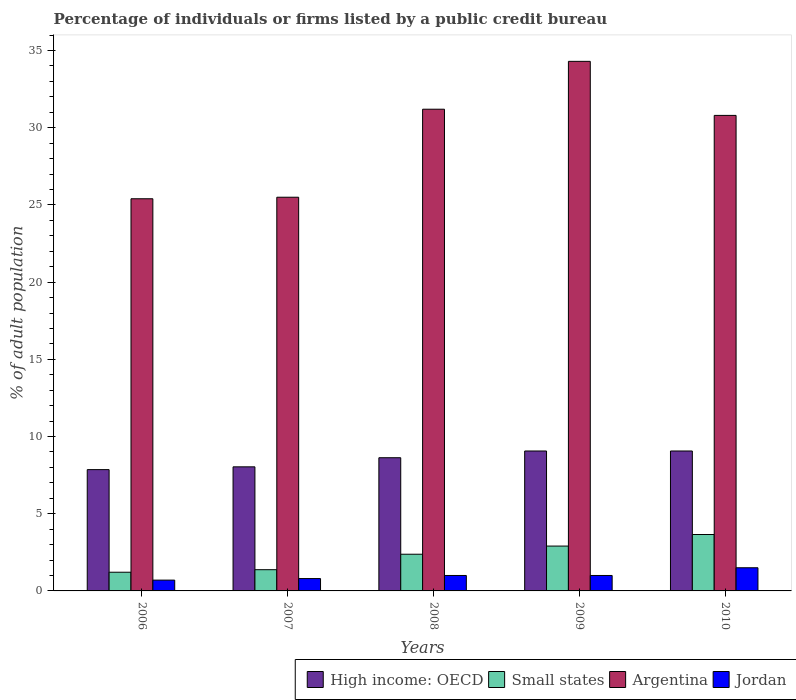How many different coloured bars are there?
Offer a terse response. 4. How many groups of bars are there?
Offer a terse response. 5. Are the number of bars per tick equal to the number of legend labels?
Your answer should be compact. Yes. Are the number of bars on each tick of the X-axis equal?
Make the answer very short. Yes. What is the label of the 3rd group of bars from the left?
Keep it short and to the point. 2008. In how many cases, is the number of bars for a given year not equal to the number of legend labels?
Give a very brief answer. 0. What is the percentage of population listed by a public credit bureau in Small states in 2008?
Make the answer very short. 2.38. Across all years, what is the maximum percentage of population listed by a public credit bureau in High income: OECD?
Ensure brevity in your answer.  9.06. Across all years, what is the minimum percentage of population listed by a public credit bureau in High income: OECD?
Your response must be concise. 7.86. In which year was the percentage of population listed by a public credit bureau in Small states maximum?
Your response must be concise. 2010. In which year was the percentage of population listed by a public credit bureau in Small states minimum?
Your response must be concise. 2006. What is the difference between the percentage of population listed by a public credit bureau in High income: OECD in 2007 and that in 2008?
Provide a short and direct response. -0.59. What is the difference between the percentage of population listed by a public credit bureau in Jordan in 2008 and the percentage of population listed by a public credit bureau in High income: OECD in 2006?
Your response must be concise. -6.86. What is the average percentage of population listed by a public credit bureau in Jordan per year?
Your answer should be very brief. 1. In the year 2007, what is the difference between the percentage of population listed by a public credit bureau in Argentina and percentage of population listed by a public credit bureau in High income: OECD?
Give a very brief answer. 17.46. In how many years, is the percentage of population listed by a public credit bureau in Small states greater than 22 %?
Your answer should be compact. 0. What is the ratio of the percentage of population listed by a public credit bureau in Small states in 2007 to that in 2009?
Offer a very short reply. 0.47. Is the percentage of population listed by a public credit bureau in Small states in 2009 less than that in 2010?
Offer a terse response. Yes. What is the difference between the highest and the lowest percentage of population listed by a public credit bureau in Argentina?
Provide a succinct answer. 8.9. In how many years, is the percentage of population listed by a public credit bureau in Small states greater than the average percentage of population listed by a public credit bureau in Small states taken over all years?
Your response must be concise. 3. What does the 2nd bar from the left in 2007 represents?
Offer a terse response. Small states. What does the 2nd bar from the right in 2009 represents?
Keep it short and to the point. Argentina. Are all the bars in the graph horizontal?
Your answer should be very brief. No. How many years are there in the graph?
Your response must be concise. 5. Are the values on the major ticks of Y-axis written in scientific E-notation?
Your answer should be compact. No. Where does the legend appear in the graph?
Your response must be concise. Bottom right. What is the title of the graph?
Keep it short and to the point. Percentage of individuals or firms listed by a public credit bureau. What is the label or title of the X-axis?
Offer a very short reply. Years. What is the label or title of the Y-axis?
Offer a very short reply. % of adult population. What is the % of adult population in High income: OECD in 2006?
Make the answer very short. 7.86. What is the % of adult population of Small states in 2006?
Offer a terse response. 1.21. What is the % of adult population of Argentina in 2006?
Ensure brevity in your answer.  25.4. What is the % of adult population of High income: OECD in 2007?
Provide a succinct answer. 8.04. What is the % of adult population in Small states in 2007?
Your answer should be very brief. 1.37. What is the % of adult population of Jordan in 2007?
Offer a very short reply. 0.8. What is the % of adult population of High income: OECD in 2008?
Make the answer very short. 8.63. What is the % of adult population in Small states in 2008?
Give a very brief answer. 2.38. What is the % of adult population in Argentina in 2008?
Provide a succinct answer. 31.2. What is the % of adult population in Jordan in 2008?
Give a very brief answer. 1. What is the % of adult population of High income: OECD in 2009?
Give a very brief answer. 9.06. What is the % of adult population of Small states in 2009?
Provide a short and direct response. 2.91. What is the % of adult population of Argentina in 2009?
Your answer should be very brief. 34.3. What is the % of adult population in High income: OECD in 2010?
Provide a succinct answer. 9.06. What is the % of adult population in Small states in 2010?
Provide a short and direct response. 3.65. What is the % of adult population in Argentina in 2010?
Keep it short and to the point. 30.8. Across all years, what is the maximum % of adult population of High income: OECD?
Your response must be concise. 9.06. Across all years, what is the maximum % of adult population of Small states?
Give a very brief answer. 3.65. Across all years, what is the maximum % of adult population in Argentina?
Your response must be concise. 34.3. Across all years, what is the minimum % of adult population in High income: OECD?
Offer a terse response. 7.86. Across all years, what is the minimum % of adult population of Small states?
Ensure brevity in your answer.  1.21. Across all years, what is the minimum % of adult population of Argentina?
Provide a short and direct response. 25.4. What is the total % of adult population in High income: OECD in the graph?
Provide a short and direct response. 42.65. What is the total % of adult population of Small states in the graph?
Your answer should be very brief. 11.52. What is the total % of adult population of Argentina in the graph?
Make the answer very short. 147.2. What is the total % of adult population of Jordan in the graph?
Your answer should be compact. 5. What is the difference between the % of adult population in High income: OECD in 2006 and that in 2007?
Provide a succinct answer. -0.18. What is the difference between the % of adult population of Small states in 2006 and that in 2007?
Keep it short and to the point. -0.16. What is the difference between the % of adult population in High income: OECD in 2006 and that in 2008?
Your answer should be compact. -0.77. What is the difference between the % of adult population of Small states in 2006 and that in 2008?
Keep it short and to the point. -1.17. What is the difference between the % of adult population in Argentina in 2006 and that in 2008?
Provide a succinct answer. -5.8. What is the difference between the % of adult population in High income: OECD in 2006 and that in 2009?
Offer a terse response. -1.21. What is the difference between the % of adult population of Small states in 2006 and that in 2009?
Your answer should be very brief. -1.69. What is the difference between the % of adult population in High income: OECD in 2006 and that in 2010?
Offer a terse response. -1.21. What is the difference between the % of adult population in Small states in 2006 and that in 2010?
Provide a short and direct response. -2.44. What is the difference between the % of adult population of High income: OECD in 2007 and that in 2008?
Ensure brevity in your answer.  -0.59. What is the difference between the % of adult population of Small states in 2007 and that in 2008?
Ensure brevity in your answer.  -1. What is the difference between the % of adult population in Argentina in 2007 and that in 2008?
Offer a very short reply. -5.7. What is the difference between the % of adult population in Jordan in 2007 and that in 2008?
Your answer should be very brief. -0.2. What is the difference between the % of adult population in High income: OECD in 2007 and that in 2009?
Provide a short and direct response. -1.03. What is the difference between the % of adult population of Small states in 2007 and that in 2009?
Give a very brief answer. -1.53. What is the difference between the % of adult population of High income: OECD in 2007 and that in 2010?
Your response must be concise. -1.03. What is the difference between the % of adult population of Small states in 2007 and that in 2010?
Offer a very short reply. -2.28. What is the difference between the % of adult population of Argentina in 2007 and that in 2010?
Offer a very short reply. -5.3. What is the difference between the % of adult population in High income: OECD in 2008 and that in 2009?
Keep it short and to the point. -0.44. What is the difference between the % of adult population in Small states in 2008 and that in 2009?
Keep it short and to the point. -0.53. What is the difference between the % of adult population of Argentina in 2008 and that in 2009?
Your answer should be very brief. -3.1. What is the difference between the % of adult population of Jordan in 2008 and that in 2009?
Your answer should be compact. 0. What is the difference between the % of adult population in High income: OECD in 2008 and that in 2010?
Offer a very short reply. -0.44. What is the difference between the % of adult population of Small states in 2008 and that in 2010?
Provide a succinct answer. -1.28. What is the difference between the % of adult population in Small states in 2009 and that in 2010?
Provide a short and direct response. -0.75. What is the difference between the % of adult population in Argentina in 2009 and that in 2010?
Make the answer very short. 3.5. What is the difference between the % of adult population in High income: OECD in 2006 and the % of adult population in Small states in 2007?
Your answer should be compact. 6.48. What is the difference between the % of adult population in High income: OECD in 2006 and the % of adult population in Argentina in 2007?
Offer a terse response. -17.64. What is the difference between the % of adult population of High income: OECD in 2006 and the % of adult population of Jordan in 2007?
Ensure brevity in your answer.  7.06. What is the difference between the % of adult population in Small states in 2006 and the % of adult population in Argentina in 2007?
Offer a terse response. -24.29. What is the difference between the % of adult population in Small states in 2006 and the % of adult population in Jordan in 2007?
Provide a succinct answer. 0.41. What is the difference between the % of adult population in Argentina in 2006 and the % of adult population in Jordan in 2007?
Give a very brief answer. 24.6. What is the difference between the % of adult population in High income: OECD in 2006 and the % of adult population in Small states in 2008?
Your answer should be compact. 5.48. What is the difference between the % of adult population of High income: OECD in 2006 and the % of adult population of Argentina in 2008?
Your response must be concise. -23.34. What is the difference between the % of adult population in High income: OECD in 2006 and the % of adult population in Jordan in 2008?
Provide a short and direct response. 6.86. What is the difference between the % of adult population in Small states in 2006 and the % of adult population in Argentina in 2008?
Provide a succinct answer. -29.99. What is the difference between the % of adult population of Small states in 2006 and the % of adult population of Jordan in 2008?
Provide a succinct answer. 0.21. What is the difference between the % of adult population of Argentina in 2006 and the % of adult population of Jordan in 2008?
Provide a short and direct response. 24.4. What is the difference between the % of adult population in High income: OECD in 2006 and the % of adult population in Small states in 2009?
Provide a succinct answer. 4.95. What is the difference between the % of adult population of High income: OECD in 2006 and the % of adult population of Argentina in 2009?
Make the answer very short. -26.44. What is the difference between the % of adult population in High income: OECD in 2006 and the % of adult population in Jordan in 2009?
Your answer should be compact. 6.86. What is the difference between the % of adult population in Small states in 2006 and the % of adult population in Argentina in 2009?
Offer a terse response. -33.09. What is the difference between the % of adult population in Small states in 2006 and the % of adult population in Jordan in 2009?
Offer a terse response. 0.21. What is the difference between the % of adult population in Argentina in 2006 and the % of adult population in Jordan in 2009?
Your answer should be very brief. 24.4. What is the difference between the % of adult population of High income: OECD in 2006 and the % of adult population of Small states in 2010?
Ensure brevity in your answer.  4.2. What is the difference between the % of adult population of High income: OECD in 2006 and the % of adult population of Argentina in 2010?
Your answer should be compact. -22.94. What is the difference between the % of adult population of High income: OECD in 2006 and the % of adult population of Jordan in 2010?
Provide a succinct answer. 6.36. What is the difference between the % of adult population of Small states in 2006 and the % of adult population of Argentina in 2010?
Offer a very short reply. -29.59. What is the difference between the % of adult population in Small states in 2006 and the % of adult population in Jordan in 2010?
Give a very brief answer. -0.29. What is the difference between the % of adult population in Argentina in 2006 and the % of adult population in Jordan in 2010?
Your response must be concise. 23.9. What is the difference between the % of adult population of High income: OECD in 2007 and the % of adult population of Small states in 2008?
Ensure brevity in your answer.  5.66. What is the difference between the % of adult population in High income: OECD in 2007 and the % of adult population in Argentina in 2008?
Your answer should be very brief. -23.16. What is the difference between the % of adult population in High income: OECD in 2007 and the % of adult population in Jordan in 2008?
Provide a short and direct response. 7.04. What is the difference between the % of adult population in Small states in 2007 and the % of adult population in Argentina in 2008?
Provide a short and direct response. -29.83. What is the difference between the % of adult population of Small states in 2007 and the % of adult population of Jordan in 2008?
Offer a very short reply. 0.37. What is the difference between the % of adult population in Argentina in 2007 and the % of adult population in Jordan in 2008?
Ensure brevity in your answer.  24.5. What is the difference between the % of adult population of High income: OECD in 2007 and the % of adult population of Small states in 2009?
Provide a short and direct response. 5.13. What is the difference between the % of adult population in High income: OECD in 2007 and the % of adult population in Argentina in 2009?
Offer a very short reply. -26.26. What is the difference between the % of adult population of High income: OECD in 2007 and the % of adult population of Jordan in 2009?
Provide a succinct answer. 7.04. What is the difference between the % of adult population of Small states in 2007 and the % of adult population of Argentina in 2009?
Your answer should be compact. -32.93. What is the difference between the % of adult population in Small states in 2007 and the % of adult population in Jordan in 2009?
Provide a succinct answer. 0.37. What is the difference between the % of adult population of High income: OECD in 2007 and the % of adult population of Small states in 2010?
Offer a very short reply. 4.38. What is the difference between the % of adult population of High income: OECD in 2007 and the % of adult population of Argentina in 2010?
Your answer should be compact. -22.76. What is the difference between the % of adult population of High income: OECD in 2007 and the % of adult population of Jordan in 2010?
Give a very brief answer. 6.54. What is the difference between the % of adult population in Small states in 2007 and the % of adult population in Argentina in 2010?
Give a very brief answer. -29.43. What is the difference between the % of adult population of Small states in 2007 and the % of adult population of Jordan in 2010?
Offer a very short reply. -0.13. What is the difference between the % of adult population of High income: OECD in 2008 and the % of adult population of Small states in 2009?
Provide a succinct answer. 5.72. What is the difference between the % of adult population of High income: OECD in 2008 and the % of adult population of Argentina in 2009?
Give a very brief answer. -25.67. What is the difference between the % of adult population of High income: OECD in 2008 and the % of adult population of Jordan in 2009?
Give a very brief answer. 7.63. What is the difference between the % of adult population in Small states in 2008 and the % of adult population in Argentina in 2009?
Give a very brief answer. -31.92. What is the difference between the % of adult population in Small states in 2008 and the % of adult population in Jordan in 2009?
Ensure brevity in your answer.  1.38. What is the difference between the % of adult population in Argentina in 2008 and the % of adult population in Jordan in 2009?
Offer a terse response. 30.2. What is the difference between the % of adult population of High income: OECD in 2008 and the % of adult population of Small states in 2010?
Your answer should be compact. 4.97. What is the difference between the % of adult population in High income: OECD in 2008 and the % of adult population in Argentina in 2010?
Offer a very short reply. -22.17. What is the difference between the % of adult population of High income: OECD in 2008 and the % of adult population of Jordan in 2010?
Provide a succinct answer. 7.13. What is the difference between the % of adult population in Small states in 2008 and the % of adult population in Argentina in 2010?
Provide a succinct answer. -28.42. What is the difference between the % of adult population in Small states in 2008 and the % of adult population in Jordan in 2010?
Offer a very short reply. 0.88. What is the difference between the % of adult population of Argentina in 2008 and the % of adult population of Jordan in 2010?
Your answer should be compact. 29.7. What is the difference between the % of adult population in High income: OECD in 2009 and the % of adult population in Small states in 2010?
Your answer should be compact. 5.41. What is the difference between the % of adult population in High income: OECD in 2009 and the % of adult population in Argentina in 2010?
Offer a terse response. -21.74. What is the difference between the % of adult population in High income: OECD in 2009 and the % of adult population in Jordan in 2010?
Ensure brevity in your answer.  7.56. What is the difference between the % of adult population of Small states in 2009 and the % of adult population of Argentina in 2010?
Offer a terse response. -27.89. What is the difference between the % of adult population in Small states in 2009 and the % of adult population in Jordan in 2010?
Offer a very short reply. 1.41. What is the difference between the % of adult population in Argentina in 2009 and the % of adult population in Jordan in 2010?
Offer a terse response. 32.8. What is the average % of adult population in High income: OECD per year?
Make the answer very short. 8.53. What is the average % of adult population of Small states per year?
Your response must be concise. 2.3. What is the average % of adult population in Argentina per year?
Ensure brevity in your answer.  29.44. In the year 2006, what is the difference between the % of adult population of High income: OECD and % of adult population of Small states?
Ensure brevity in your answer.  6.65. In the year 2006, what is the difference between the % of adult population in High income: OECD and % of adult population in Argentina?
Ensure brevity in your answer.  -17.54. In the year 2006, what is the difference between the % of adult population in High income: OECD and % of adult population in Jordan?
Your answer should be very brief. 7.16. In the year 2006, what is the difference between the % of adult population in Small states and % of adult population in Argentina?
Your answer should be very brief. -24.19. In the year 2006, what is the difference between the % of adult population in Small states and % of adult population in Jordan?
Keep it short and to the point. 0.51. In the year 2006, what is the difference between the % of adult population of Argentina and % of adult population of Jordan?
Your answer should be very brief. 24.7. In the year 2007, what is the difference between the % of adult population in High income: OECD and % of adult population in Small states?
Ensure brevity in your answer.  6.66. In the year 2007, what is the difference between the % of adult population of High income: OECD and % of adult population of Argentina?
Your response must be concise. -17.46. In the year 2007, what is the difference between the % of adult population in High income: OECD and % of adult population in Jordan?
Give a very brief answer. 7.24. In the year 2007, what is the difference between the % of adult population of Small states and % of adult population of Argentina?
Provide a short and direct response. -24.13. In the year 2007, what is the difference between the % of adult population in Small states and % of adult population in Jordan?
Provide a succinct answer. 0.57. In the year 2007, what is the difference between the % of adult population of Argentina and % of adult population of Jordan?
Offer a terse response. 24.7. In the year 2008, what is the difference between the % of adult population in High income: OECD and % of adult population in Small states?
Your response must be concise. 6.25. In the year 2008, what is the difference between the % of adult population in High income: OECD and % of adult population in Argentina?
Ensure brevity in your answer.  -22.57. In the year 2008, what is the difference between the % of adult population of High income: OECD and % of adult population of Jordan?
Keep it short and to the point. 7.63. In the year 2008, what is the difference between the % of adult population of Small states and % of adult population of Argentina?
Make the answer very short. -28.82. In the year 2008, what is the difference between the % of adult population in Small states and % of adult population in Jordan?
Your response must be concise. 1.38. In the year 2008, what is the difference between the % of adult population of Argentina and % of adult population of Jordan?
Keep it short and to the point. 30.2. In the year 2009, what is the difference between the % of adult population in High income: OECD and % of adult population in Small states?
Make the answer very short. 6.16. In the year 2009, what is the difference between the % of adult population of High income: OECD and % of adult population of Argentina?
Ensure brevity in your answer.  -25.24. In the year 2009, what is the difference between the % of adult population of High income: OECD and % of adult population of Jordan?
Give a very brief answer. 8.06. In the year 2009, what is the difference between the % of adult population in Small states and % of adult population in Argentina?
Give a very brief answer. -31.39. In the year 2009, what is the difference between the % of adult population of Small states and % of adult population of Jordan?
Provide a succinct answer. 1.91. In the year 2009, what is the difference between the % of adult population in Argentina and % of adult population in Jordan?
Your answer should be compact. 33.3. In the year 2010, what is the difference between the % of adult population in High income: OECD and % of adult population in Small states?
Provide a succinct answer. 5.41. In the year 2010, what is the difference between the % of adult population of High income: OECD and % of adult population of Argentina?
Keep it short and to the point. -21.74. In the year 2010, what is the difference between the % of adult population in High income: OECD and % of adult population in Jordan?
Provide a succinct answer. 7.56. In the year 2010, what is the difference between the % of adult population of Small states and % of adult population of Argentina?
Provide a succinct answer. -27.15. In the year 2010, what is the difference between the % of adult population in Small states and % of adult population in Jordan?
Give a very brief answer. 2.15. In the year 2010, what is the difference between the % of adult population in Argentina and % of adult population in Jordan?
Make the answer very short. 29.3. What is the ratio of the % of adult population of High income: OECD in 2006 to that in 2007?
Keep it short and to the point. 0.98. What is the ratio of the % of adult population in Small states in 2006 to that in 2007?
Offer a very short reply. 0.88. What is the ratio of the % of adult population of Jordan in 2006 to that in 2007?
Give a very brief answer. 0.88. What is the ratio of the % of adult population in High income: OECD in 2006 to that in 2008?
Keep it short and to the point. 0.91. What is the ratio of the % of adult population in Small states in 2006 to that in 2008?
Your response must be concise. 0.51. What is the ratio of the % of adult population of Argentina in 2006 to that in 2008?
Provide a succinct answer. 0.81. What is the ratio of the % of adult population of High income: OECD in 2006 to that in 2009?
Offer a very short reply. 0.87. What is the ratio of the % of adult population of Small states in 2006 to that in 2009?
Keep it short and to the point. 0.42. What is the ratio of the % of adult population in Argentina in 2006 to that in 2009?
Ensure brevity in your answer.  0.74. What is the ratio of the % of adult population in Jordan in 2006 to that in 2009?
Offer a very short reply. 0.7. What is the ratio of the % of adult population in High income: OECD in 2006 to that in 2010?
Ensure brevity in your answer.  0.87. What is the ratio of the % of adult population of Small states in 2006 to that in 2010?
Your response must be concise. 0.33. What is the ratio of the % of adult population of Argentina in 2006 to that in 2010?
Offer a terse response. 0.82. What is the ratio of the % of adult population in Jordan in 2006 to that in 2010?
Your answer should be compact. 0.47. What is the ratio of the % of adult population in High income: OECD in 2007 to that in 2008?
Offer a terse response. 0.93. What is the ratio of the % of adult population of Small states in 2007 to that in 2008?
Your answer should be compact. 0.58. What is the ratio of the % of adult population in Argentina in 2007 to that in 2008?
Your answer should be compact. 0.82. What is the ratio of the % of adult population in High income: OECD in 2007 to that in 2009?
Offer a very short reply. 0.89. What is the ratio of the % of adult population in Small states in 2007 to that in 2009?
Ensure brevity in your answer.  0.47. What is the ratio of the % of adult population in Argentina in 2007 to that in 2009?
Offer a terse response. 0.74. What is the ratio of the % of adult population of Jordan in 2007 to that in 2009?
Give a very brief answer. 0.8. What is the ratio of the % of adult population in High income: OECD in 2007 to that in 2010?
Your answer should be very brief. 0.89. What is the ratio of the % of adult population of Small states in 2007 to that in 2010?
Offer a very short reply. 0.38. What is the ratio of the % of adult population in Argentina in 2007 to that in 2010?
Give a very brief answer. 0.83. What is the ratio of the % of adult population of Jordan in 2007 to that in 2010?
Provide a short and direct response. 0.53. What is the ratio of the % of adult population of High income: OECD in 2008 to that in 2009?
Your response must be concise. 0.95. What is the ratio of the % of adult population in Small states in 2008 to that in 2009?
Your response must be concise. 0.82. What is the ratio of the % of adult population of Argentina in 2008 to that in 2009?
Your answer should be very brief. 0.91. What is the ratio of the % of adult population of Jordan in 2008 to that in 2009?
Offer a very short reply. 1. What is the ratio of the % of adult population in High income: OECD in 2008 to that in 2010?
Make the answer very short. 0.95. What is the ratio of the % of adult population of Small states in 2008 to that in 2010?
Your response must be concise. 0.65. What is the ratio of the % of adult population in Argentina in 2008 to that in 2010?
Offer a very short reply. 1.01. What is the ratio of the % of adult population of Small states in 2009 to that in 2010?
Keep it short and to the point. 0.8. What is the ratio of the % of adult population in Argentina in 2009 to that in 2010?
Offer a very short reply. 1.11. What is the ratio of the % of adult population of Jordan in 2009 to that in 2010?
Offer a terse response. 0.67. What is the difference between the highest and the second highest % of adult population of High income: OECD?
Your answer should be compact. 0. What is the difference between the highest and the second highest % of adult population of Small states?
Provide a short and direct response. 0.75. What is the difference between the highest and the second highest % of adult population of Argentina?
Make the answer very short. 3.1. What is the difference between the highest and the second highest % of adult population in Jordan?
Make the answer very short. 0.5. What is the difference between the highest and the lowest % of adult population in High income: OECD?
Offer a terse response. 1.21. What is the difference between the highest and the lowest % of adult population in Small states?
Your answer should be compact. 2.44. What is the difference between the highest and the lowest % of adult population of Jordan?
Your response must be concise. 0.8. 